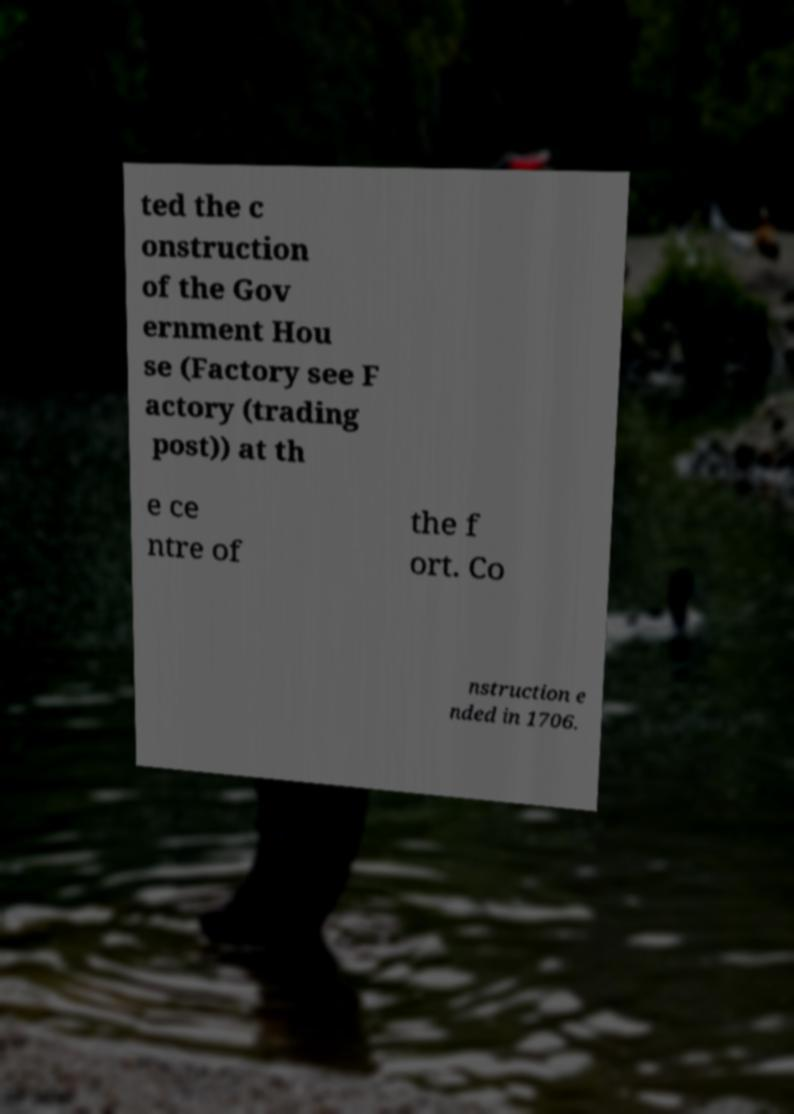There's text embedded in this image that I need extracted. Can you transcribe it verbatim? ted the c onstruction of the Gov ernment Hou se (Factory see F actory (trading post)) at th e ce ntre of the f ort. Co nstruction e nded in 1706. 